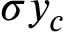Convert formula to latex. <formula><loc_0><loc_0><loc_500><loc_500>\sigma y _ { c }</formula> 